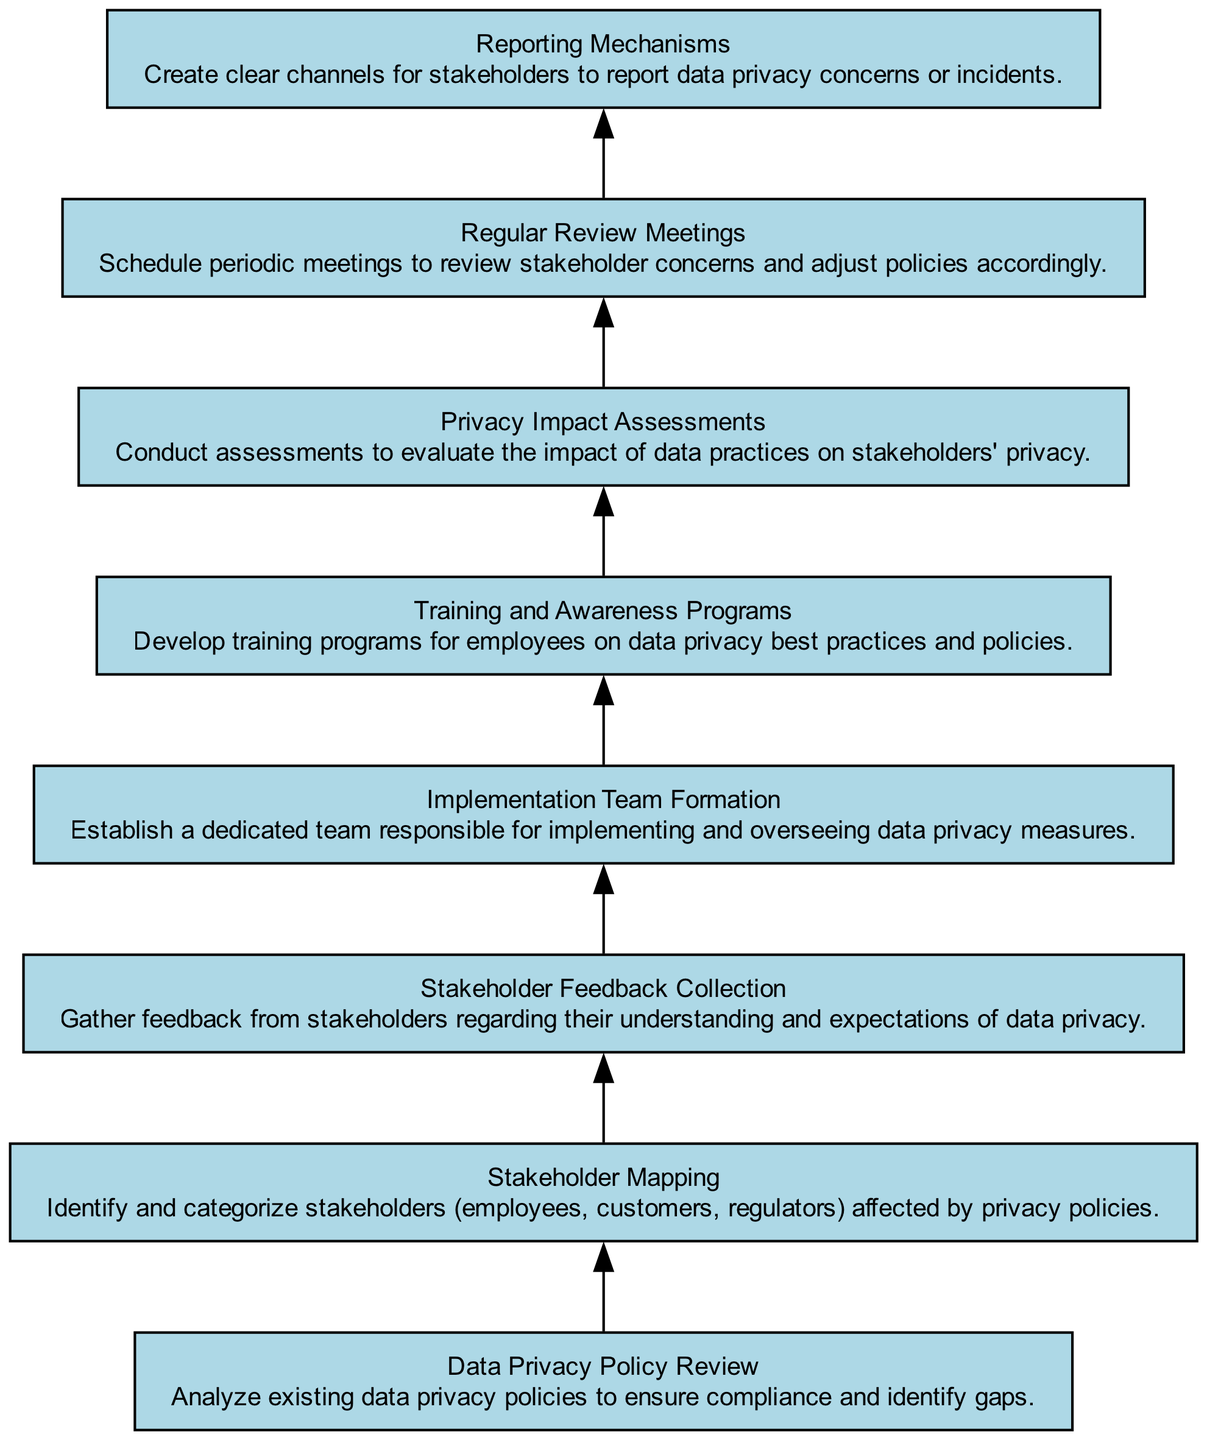What's the first node in the diagram? The first node is labeled "Data Privacy Policy Review" and is situated at the bottom of the diagram. This node represents the starting point of the flow.
Answer: Data Privacy Policy Review How many total nodes are present in the diagram? By counting each unique element listed in the data, there are eight distinct nodes present in the diagram.
Answer: 8 What is the main purpose of the "Stakeholder Mapping" node? The "Stakeholder Mapping" node's purpose is to identify and categorize the stakeholders affected by the privacy policies. It’s positioned as the second step in the flow.
Answer: Identify and categorize stakeholders Which node follows "Privacy Impact Assessments"? The node that follows "Privacy Impact Assessments" is "Regular Review Meetings", indicating a step that involves meeting to address concerns after the assessments are completed.
Answer: Regular Review Meetings What type of engagement does the "Stakeholder Feedback Collection" node focus on? The focus of "Stakeholder Feedback Collection" is to gather input from stakeholders regarding their expectations and understanding of data privacy policies. It's significant as it serves to inform policy adjustment.
Answer: Feedback from stakeholders Which two nodes are primarily focused on training and awareness? The nodes focused on training and awareness are "Training and Awareness Programs" and "Reporting Mechanisms"; while one provides training, the other establishes channels for reporting issues, indicating a comprehensive approach to awareness.
Answer: Training and Awareness Programs, Reporting Mechanisms How do the nodes relate in terms of feedback and adjustment? Feedback from "Stakeholder Feedback Collection" feeds into the "Regular Review Meetings", which then influences adjustments to policies, showing a cyclical relationship of feedback leading to policy refinement.
Answer: Feedback leading to policy refinement What is the endpoint of the diagram? The diagram does not explicitly label one endpoint; however, "Reporting Mechanisms" can be considered the endpoint as it provides channels for continuing engagement based on the policies established throughout the process.
Answer: Reporting Mechanisms 